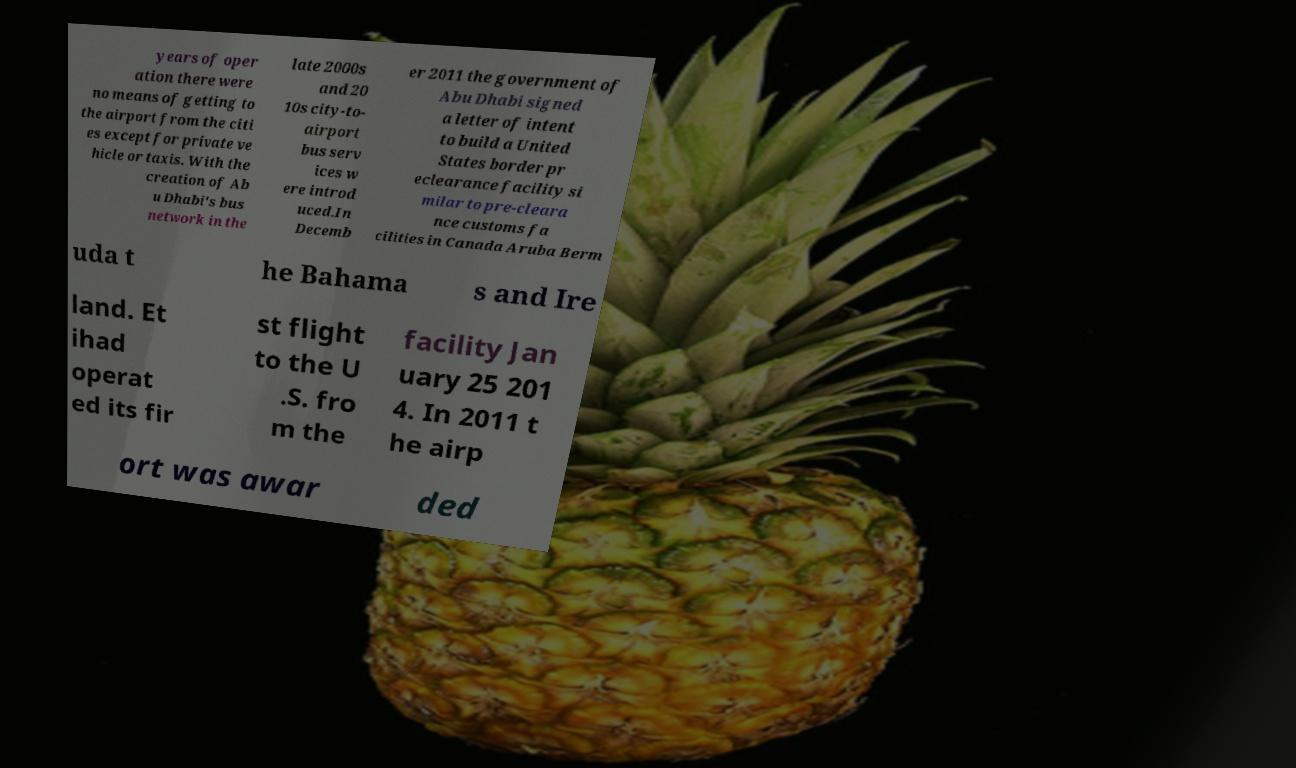Can you read and provide the text displayed in the image?This photo seems to have some interesting text. Can you extract and type it out for me? years of oper ation there were no means of getting to the airport from the citi es except for private ve hicle or taxis. With the creation of Ab u Dhabi's bus network in the late 2000s and 20 10s city-to- airport bus serv ices w ere introd uced.In Decemb er 2011 the government of Abu Dhabi signed a letter of intent to build a United States border pr eclearance facility si milar to pre-cleara nce customs fa cilities in Canada Aruba Berm uda t he Bahama s and Ire land. Et ihad operat ed its fir st flight to the U .S. fro m the facility Jan uary 25 201 4. In 2011 t he airp ort was awar ded 